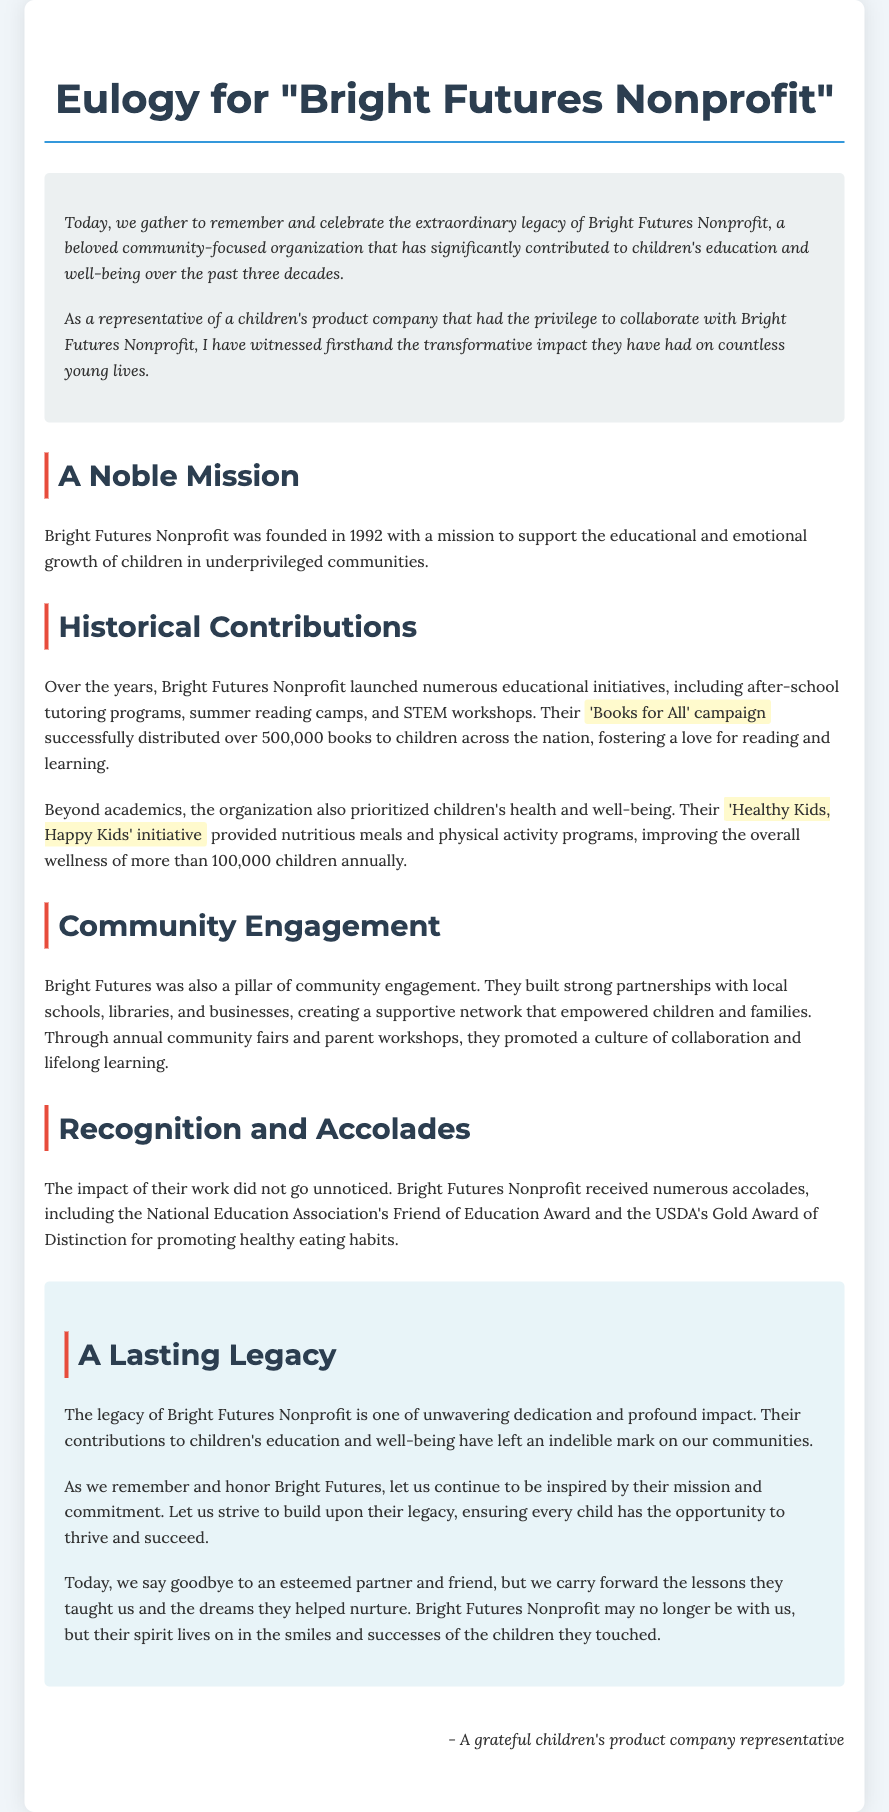What year was Bright Futures Nonprofit founded? The document states that Bright Futures Nonprofit was founded in 1992.
Answer: 1992 What initiative distributed over 500,000 books? The highlighted initiative in the document is the 'Books for All' campaign.
Answer: 'Books for All' campaign How many children benefited from the 'Healthy Kids, Happy Kids' initiative? The document mentions that more than 100,000 children benefited annually from this initiative.
Answer: More than 100,000 What award did Bright Futures Nonprofit receive from the USDA? The document lists the USDA's Gold Award of Distinction as an accolade received by the organization.
Answer: Gold Award of Distinction What was a key aspect of the nonprofit's community engagement? The document emphasizes building strong partnerships with local schools, libraries, and businesses.
Answer: Partnerships What is the main focus of Bright Futures Nonprofit's mission? According to the document, their mission focuses on supporting educational and emotional growth of children.
Answer: Educational and emotional growth What element of the eulogy highlights the impact of Bright Futures Nonprofit on communities? The eulogy states their legacy represents unwavering dedication and profound impact.
Answer: Unwavering dedication and profound impact Who is the speaker of the eulogy? The document indicates that it is a grateful children's product company representative.
Answer: A grateful children's product company representative 